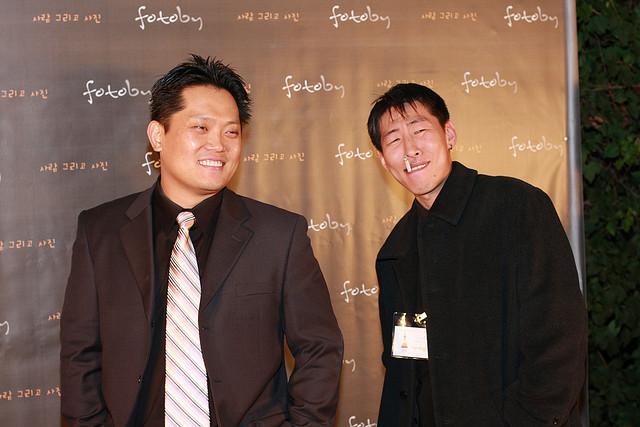What ethnicity are the people?
Answer briefly. Asian. What outerwear are the men wearing?
Give a very brief answer. Suit jackets. Are the people female?
Write a very short answer. No. 